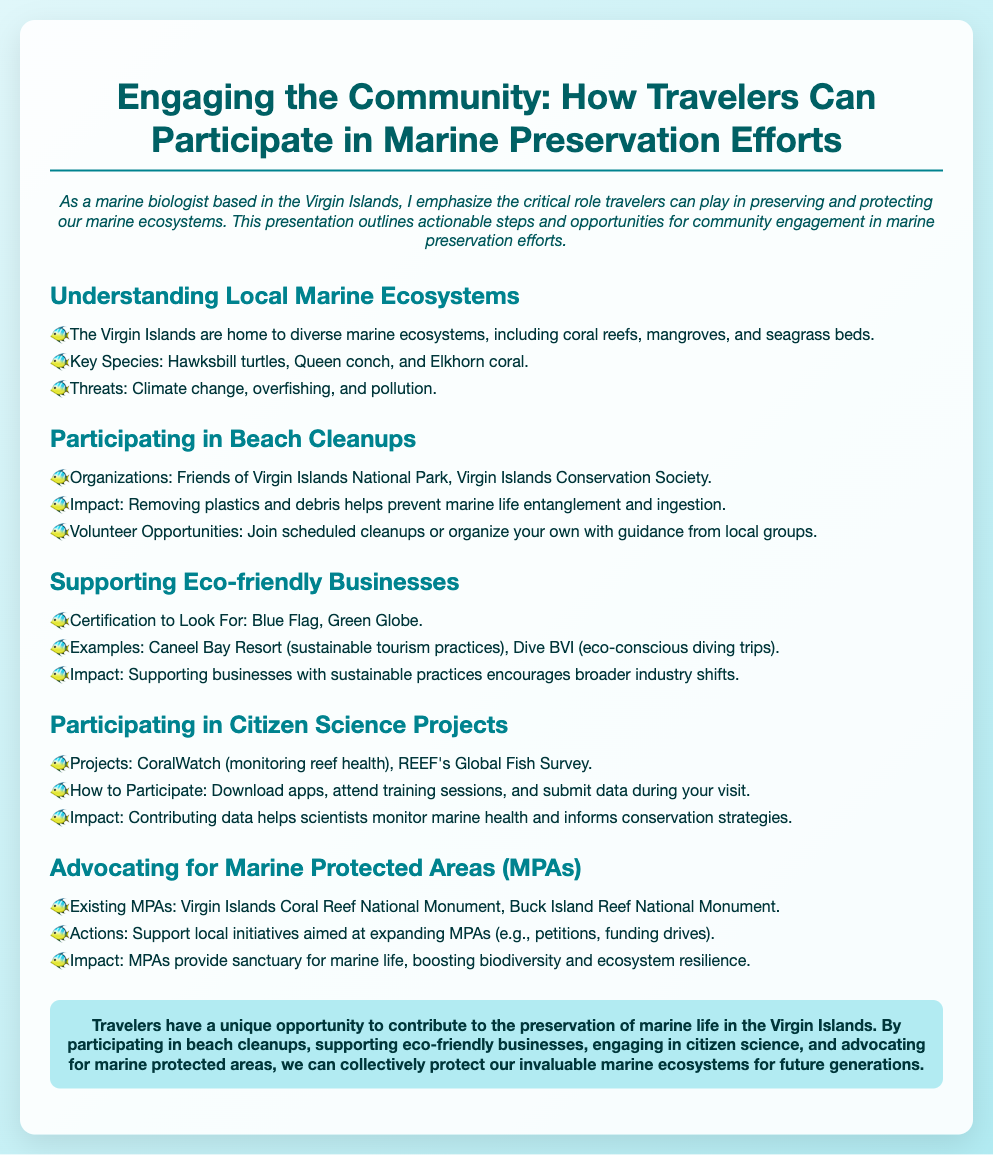What are the key species found in the Virgin Islands? The document lists Hawksbill turtles, Queen conch, and Elkhorn coral as key species.
Answer: Hawksbill turtles, Queen conch, Elkhorn coral Which organizations are involved in beach cleanups? The document mentions Friends of Virgin Islands National Park and Virgin Islands Conservation Society as organizations for beach cleanups.
Answer: Friends of Virgin Islands National Park, Virgin Islands Conservation Society What certification should travelers look for when supporting eco-friendly businesses? The document advises looking for Blue Flag and Green Globe certifications.
Answer: Blue Flag, Green Globe What is the title of the citizen science project related to monitoring reef health? The project mentioned in the document for monitoring reef health is CoralWatch.
Answer: CoralWatch How can travelers participate in citizen science projects? The document explains that participants can download apps, attend training sessions, and submit data during their visit.
Answer: Download apps, attend training sessions, submit data What impact do Marine Protected Areas have on biodiversity? The document states that MPAs provide sanctuary for marine life, boosting biodiversity and ecosystem resilience.
Answer: Boosting biodiversity and ecosystem resilience What is the conclusion about travelers' opportunities in marine preservation? The conclusion emphasizes that travelers can contribute to the preservation of marine life through various actions outlined in the presentation.
Answer: Travelers can contribute to marine life preservation 